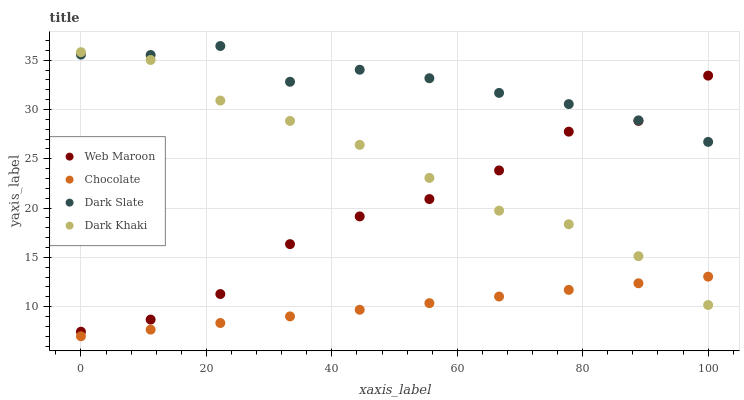Does Chocolate have the minimum area under the curve?
Answer yes or no. Yes. Does Dark Slate have the maximum area under the curve?
Answer yes or no. Yes. Does Web Maroon have the minimum area under the curve?
Answer yes or no. No. Does Web Maroon have the maximum area under the curve?
Answer yes or no. No. Is Chocolate the smoothest?
Answer yes or no. Yes. Is Web Maroon the roughest?
Answer yes or no. Yes. Is Dark Slate the smoothest?
Answer yes or no. No. Is Dark Slate the roughest?
Answer yes or no. No. Does Chocolate have the lowest value?
Answer yes or no. Yes. Does Web Maroon have the lowest value?
Answer yes or no. No. Does Dark Slate have the highest value?
Answer yes or no. Yes. Does Web Maroon have the highest value?
Answer yes or no. No. Is Chocolate less than Dark Slate?
Answer yes or no. Yes. Is Dark Slate greater than Chocolate?
Answer yes or no. Yes. Does Web Maroon intersect Dark Khaki?
Answer yes or no. Yes. Is Web Maroon less than Dark Khaki?
Answer yes or no. No. Is Web Maroon greater than Dark Khaki?
Answer yes or no. No. Does Chocolate intersect Dark Slate?
Answer yes or no. No. 